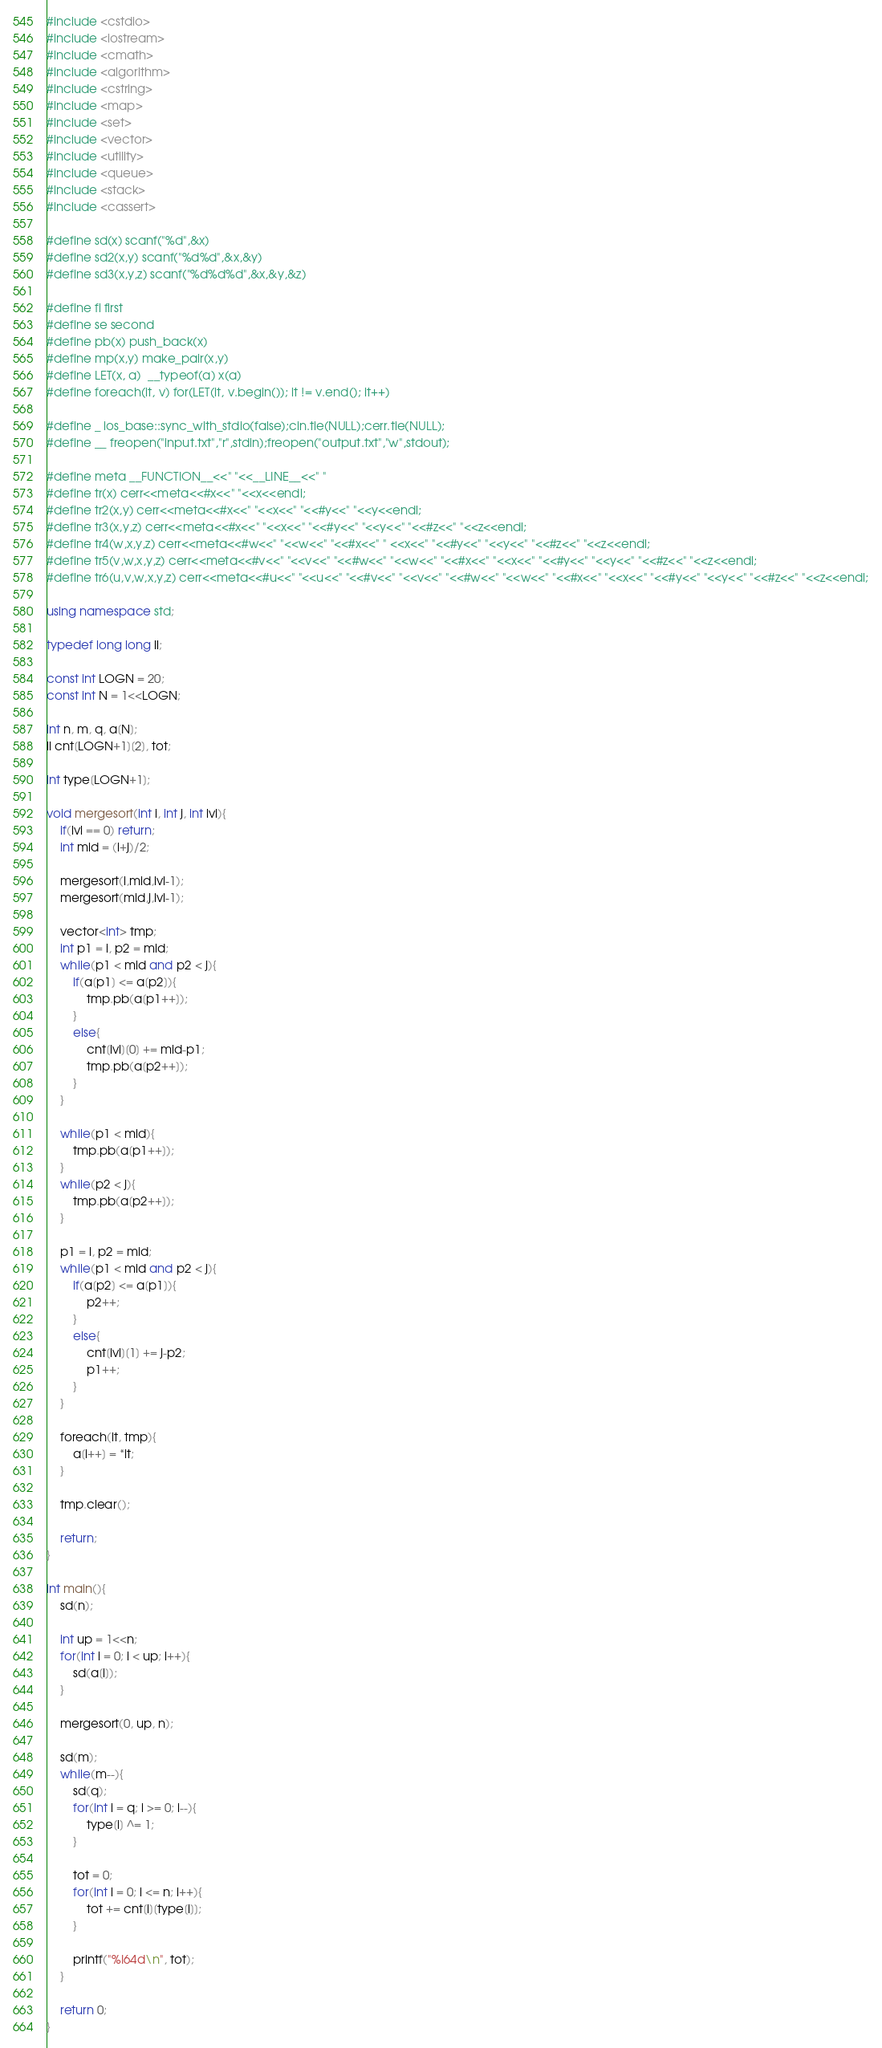<code> <loc_0><loc_0><loc_500><loc_500><_C++_>#include <cstdio>
#include <iostream>
#include <cmath>
#include <algorithm>
#include <cstring>
#include <map>
#include <set>
#include <vector>
#include <utility>
#include <queue>
#include <stack>
#include <cassert>

#define sd(x) scanf("%d",&x)
#define sd2(x,y) scanf("%d%d",&x,&y)
#define sd3(x,y,z) scanf("%d%d%d",&x,&y,&z)

#define fi first
#define se second
#define pb(x) push_back(x)
#define mp(x,y) make_pair(x,y)
#define LET(x, a)  __typeof(a) x(a)
#define foreach(it, v) for(LET(it, v.begin()); it != v.end(); it++)

#define _ ios_base::sync_with_stdio(false);cin.tie(NULL);cerr.tie(NULL);
#define __ freopen("input.txt","r",stdin);freopen("output.txt","w",stdout);

#define meta __FUNCTION__<<" "<<__LINE__<<" "
#define tr(x) cerr<<meta<<#x<<" "<<x<<endl;
#define tr2(x,y) cerr<<meta<<#x<<" "<<x<<" "<<#y<<" "<<y<<endl;
#define tr3(x,y,z) cerr<<meta<<#x<<" "<<x<<" "<<#y<<" "<<y<<" "<<#z<<" "<<z<<endl;
#define tr4(w,x,y,z) cerr<<meta<<#w<<" "<<w<<" "<<#x<<" " <<x<<" "<<#y<<" "<<y<<" "<<#z<<" "<<z<<endl;
#define tr5(v,w,x,y,z) cerr<<meta<<#v<<" "<<v<<" "<<#w<<" "<<w<<" "<<#x<<" "<<x<<" "<<#y<<" "<<y<<" "<<#z<<" "<<z<<endl;
#define tr6(u,v,w,x,y,z) cerr<<meta<<#u<<" "<<u<<" "<<#v<<" "<<v<<" "<<#w<<" "<<w<<" "<<#x<<" "<<x<<" "<<#y<<" "<<y<<" "<<#z<<" "<<z<<endl;

using namespace std;

typedef long long ll;

const int LOGN = 20;
const int N = 1<<LOGN;

int n, m, q, a[N];
ll cnt[LOGN+1][2], tot;

int type[LOGN+1];

void mergesort(int i, int j, int lvl){
	if(lvl == 0) return;
	int mid = (i+j)/2;
	
	mergesort(i,mid,lvl-1);
	mergesort(mid,j,lvl-1);
	
	vector<int> tmp;
	int p1 = i, p2 = mid;
	while(p1 < mid and p2 < j){
		if(a[p1] <= a[p2]){
			tmp.pb(a[p1++]);
		}
		else{
			cnt[lvl][0] += mid-p1;
			tmp.pb(a[p2++]);			
		}
	}
	
	while(p1 < mid){
		tmp.pb(a[p1++]);
	}
	while(p2 < j){
		tmp.pb(a[p2++]);
	}
	
	p1 = i, p2 = mid;
	while(p1 < mid and p2 < j){
		if(a[p2] <= a[p1]){
			p2++;
		}
		else{
			cnt[lvl][1] += j-p2;
			p1++;
		}
	}
	
	foreach(it, tmp){
		a[i++] = *it;
	}
	
	tmp.clear();
	
	return;
}

int main(){
	sd(n);
	
	int up = 1<<n;
	for(int i = 0; i < up; i++){
		sd(a[i]);
	}
	
	mergesort(0, up, n);

	sd(m);
	while(m--){
		sd(q);
		for(int i = q; i >= 0; i--){
			type[i] ^= 1;
		}
		
		tot = 0;		
		for(int i = 0; i <= n; i++){
			tot += cnt[i][type[i]];
		}

		printf("%I64d\n", tot);
	}

	return 0;
}
</code> 